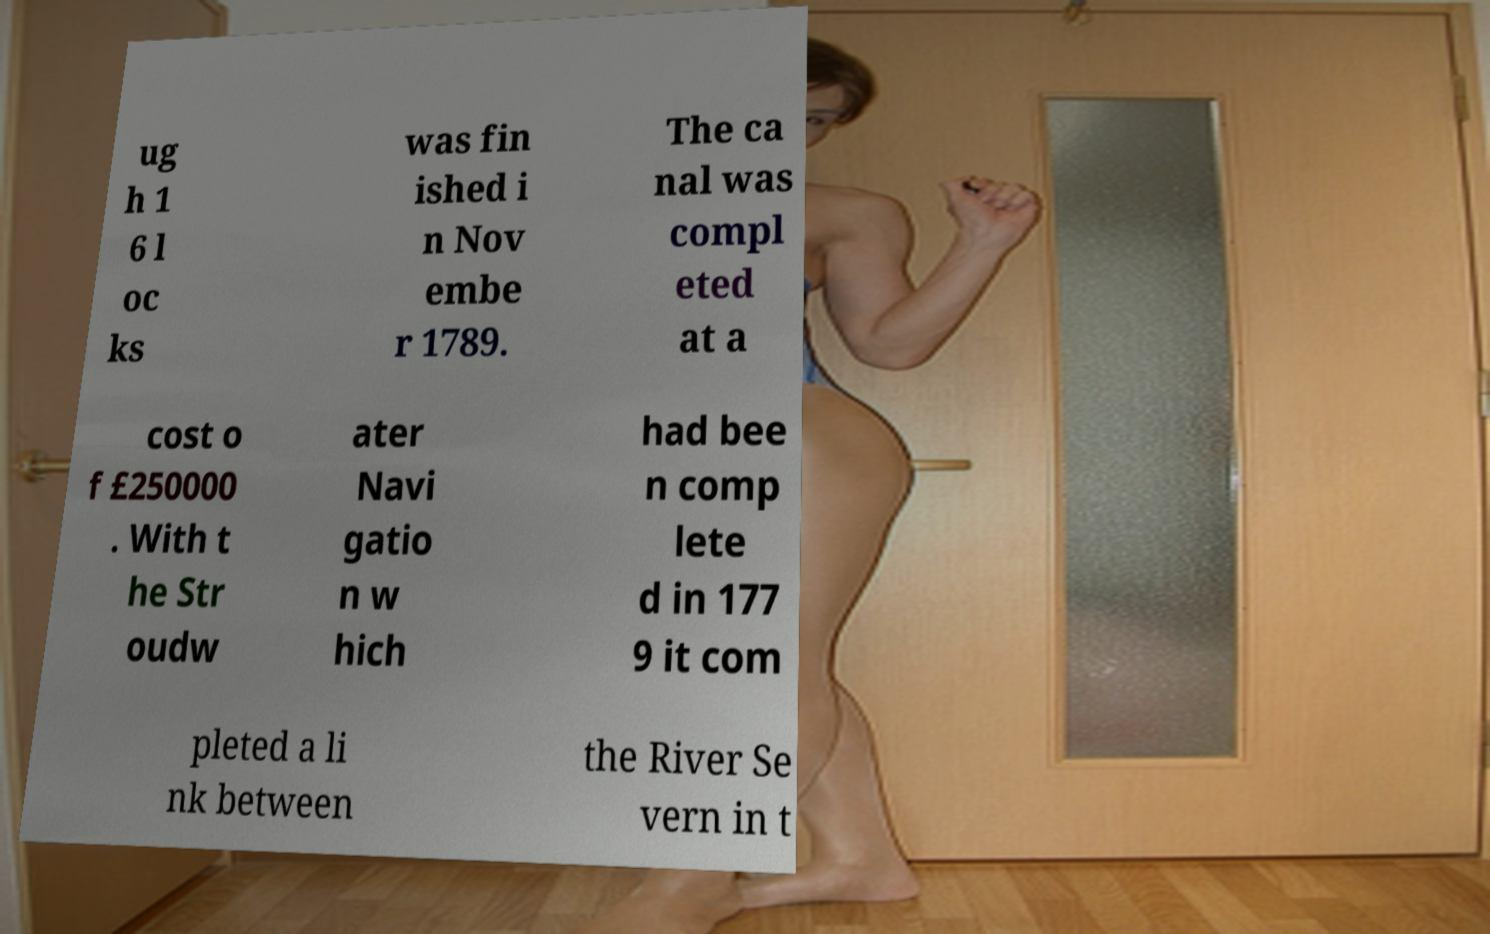Please read and relay the text visible in this image. What does it say? ug h 1 6 l oc ks was fin ished i n Nov embe r 1789. The ca nal was compl eted at a cost o f £250000 . With t he Str oudw ater Navi gatio n w hich had bee n comp lete d in 177 9 it com pleted a li nk between the River Se vern in t 